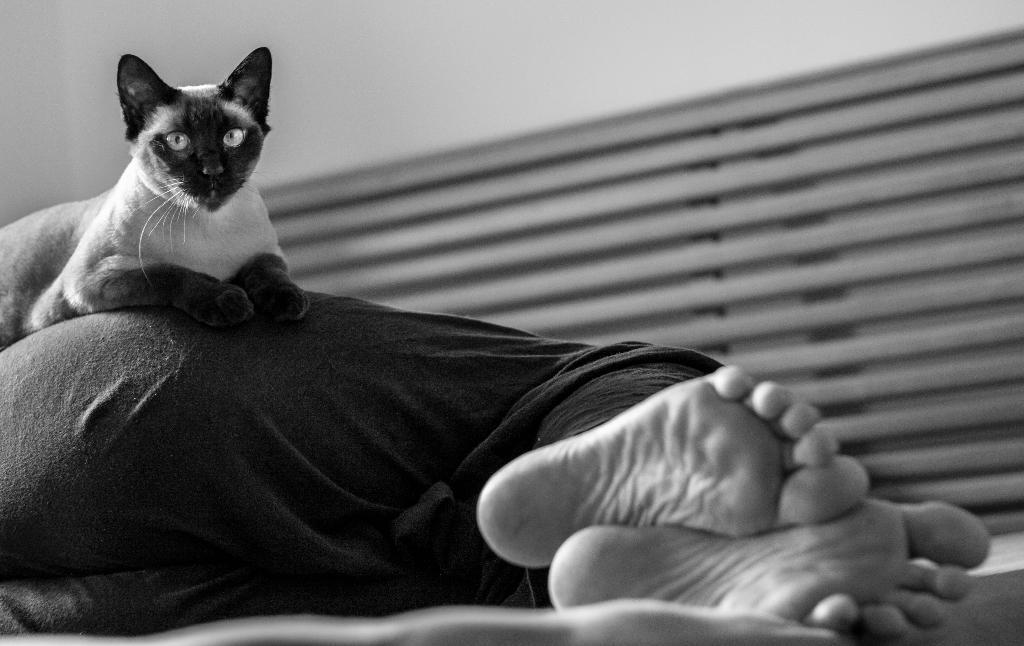Can you describe this image briefly? In this picture, we see a person is sleeping on the bed. We see a cat is sitting on the person. In the background, we see the window blind. At the top, we see a wall. This is a black and white picture. 